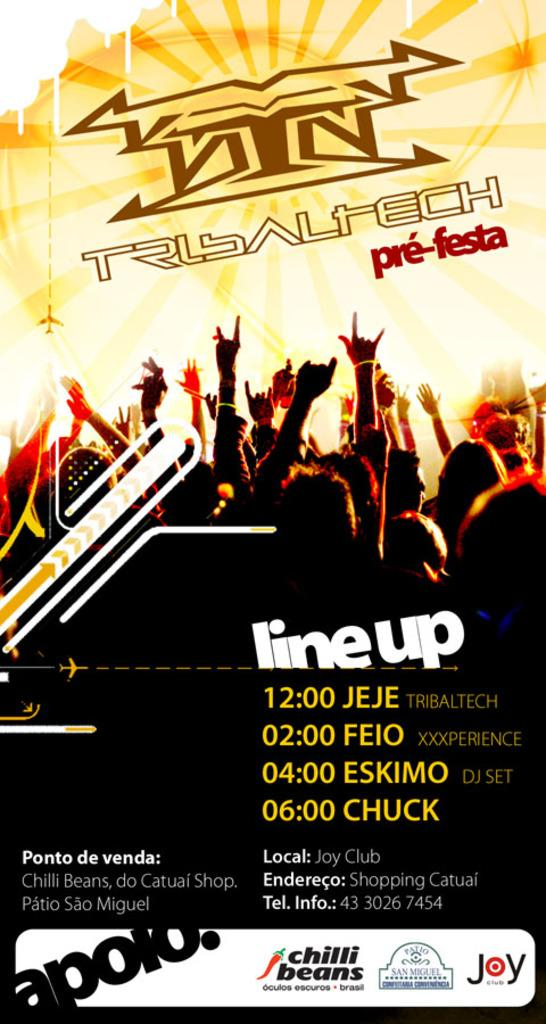<image>
Present a compact description of the photo's key features. A poster lists the times 12:00, 2:00, 4:00, and 6:00. 